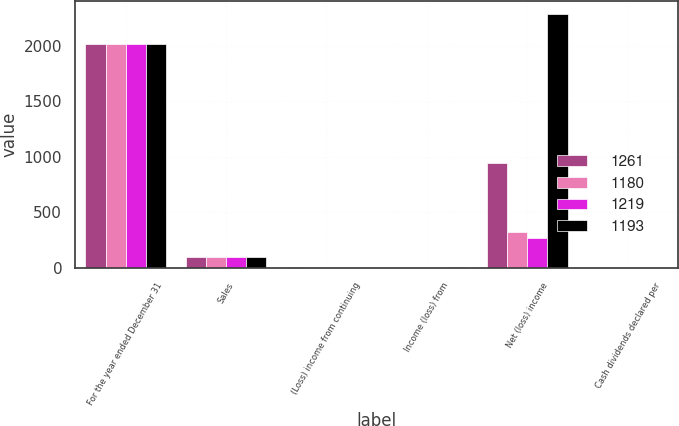<chart> <loc_0><loc_0><loc_500><loc_500><stacked_bar_chart><ecel><fcel>For the year ended December 31<fcel>Sales<fcel>(Loss) income from continuing<fcel>Income (loss) from<fcel>Net (loss) income<fcel>Cash dividends declared per<nl><fcel>1261<fcel>2016<fcel>92<fcel>2.58<fcel>0.27<fcel>941<fcel>0.36<nl><fcel>1180<fcel>2015<fcel>92<fcel>0.54<fcel>0.39<fcel>322<fcel>0.36<nl><fcel>1219<fcel>2014<fcel>92<fcel>0.21<fcel>0.85<fcel>268<fcel>0.36<nl><fcel>1193<fcel>2013<fcel>92<fcel>0.18<fcel>6.23<fcel>2285<fcel>0.36<nl></chart> 